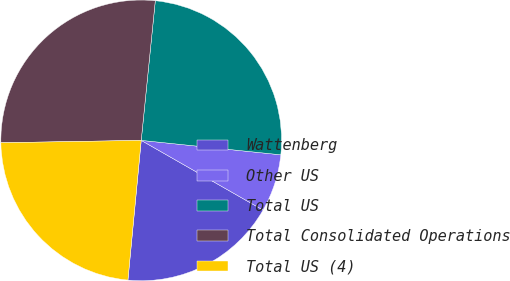Convert chart to OTSL. <chart><loc_0><loc_0><loc_500><loc_500><pie_chart><fcel>Wattenberg<fcel>Other US<fcel>Total US<fcel>Total Consolidated Operations<fcel>Total US (4)<nl><fcel>18.24%<fcel>6.63%<fcel>25.04%<fcel>26.87%<fcel>23.22%<nl></chart> 